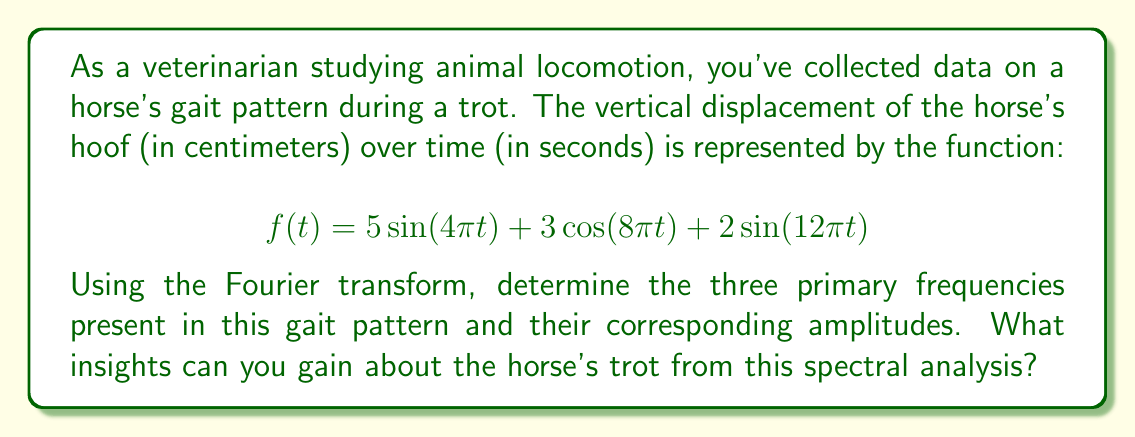What is the answer to this math problem? To analyze the spectral content of the horse's gait pattern, we need to identify the frequencies and amplitudes in the given function. The Fourier transform is an ideal tool for this purpose.

1. Recall that the general form of a sinusoidal function is:

   $$A\sin(2\pi ft) \text{ or } A\cos(2\pi ft)$$

   where $A$ is the amplitude and $f$ is the frequency in Hz.

2. Let's break down the given function:

   $$f(t) = 5\sin(4\pi t) + 3\cos(8\pi t) + 2\sin(12\pi t)$$

3. For the first term, $5\sin(4\pi t)$:
   - Amplitude: $A_1 = 5$
   - Frequency: $4\pi = 2\pi f_1$, so $f_1 = 2$ Hz

4. For the second term, $3\cos(8\pi t)$:
   - Amplitude: $A_2 = 3$
   - Frequency: $8\pi = 2\pi f_2$, so $f_2 = 4$ Hz

5. For the third term, $2\sin(12\pi t)$:
   - Amplitude: $A_3 = 2$
   - Frequency: $12\pi = 2\pi f_3$, so $f_3 = 6$ Hz

6. Insights from this spectral analysis:
   - The horse's trot contains three primary frequency components: 2 Hz, 4 Hz, and 6 Hz.
   - The 2 Hz component has the highest amplitude, suggesting it's the fundamental frequency of the trot.
   - The presence of higher frequencies (4 Hz and 6 Hz) indicates complexity in the gait pattern, possibly related to the alternating diagonal limb pairs characteristic of a trot.
   - The decreasing amplitudes at higher frequencies suggest a natural damping effect in the horse's locomotion.
Answer: The three primary frequencies and their corresponding amplitudes are:
1. $f_1 = 2$ Hz, $A_1 = 5$ cm
2. $f_2 = 4$ Hz, $A_2 = 3$ cm
3. $f_3 = 6$ Hz, $A_3 = 2$ cm

This spectral analysis reveals a fundamental trot frequency of 2 Hz with higher harmonics, indicating a complex but structured gait pattern typical of a horse's trot. 